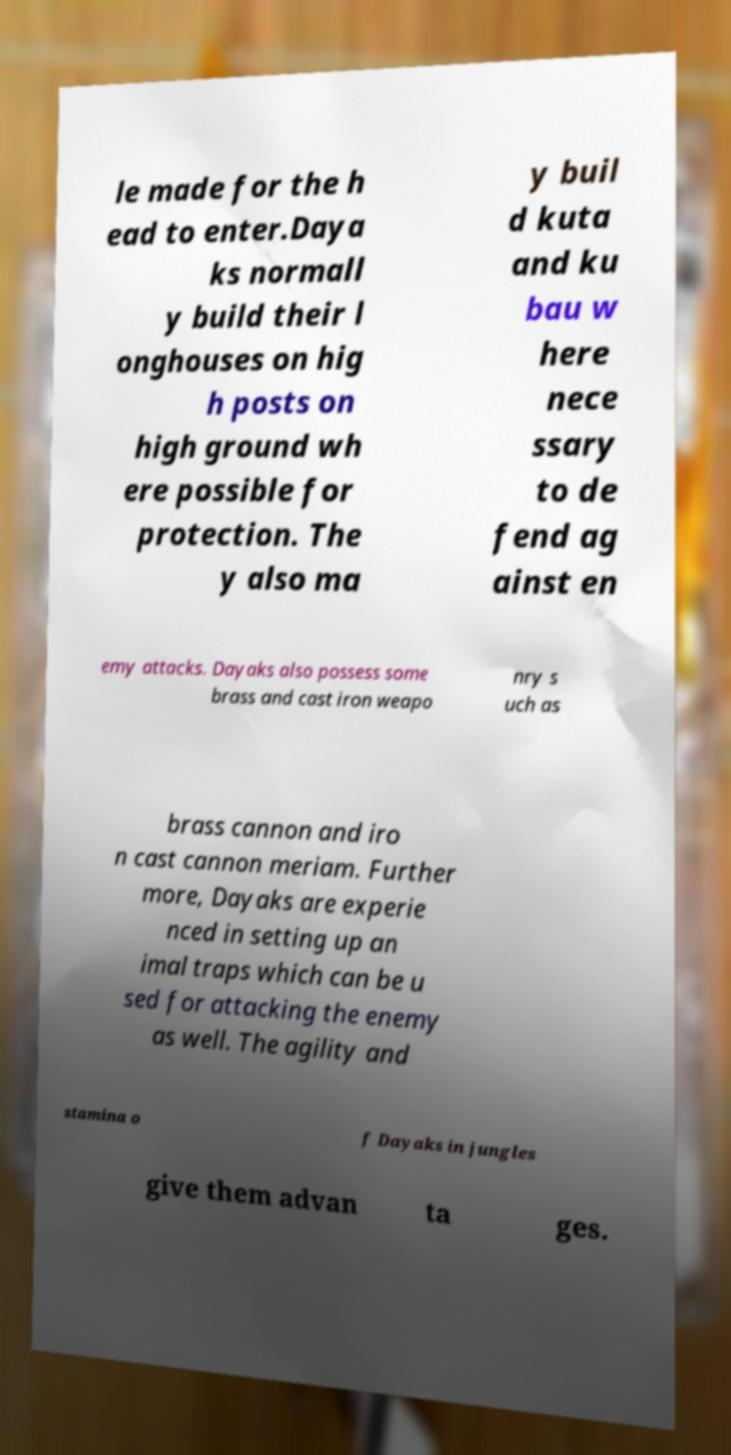For documentation purposes, I need the text within this image transcribed. Could you provide that? le made for the h ead to enter.Daya ks normall y build their l onghouses on hig h posts on high ground wh ere possible for protection. The y also ma y buil d kuta and ku bau w here nece ssary to de fend ag ainst en emy attacks. Dayaks also possess some brass and cast iron weapo nry s uch as brass cannon and iro n cast cannon meriam. Further more, Dayaks are experie nced in setting up an imal traps which can be u sed for attacking the enemy as well. The agility and stamina o f Dayaks in jungles give them advan ta ges. 